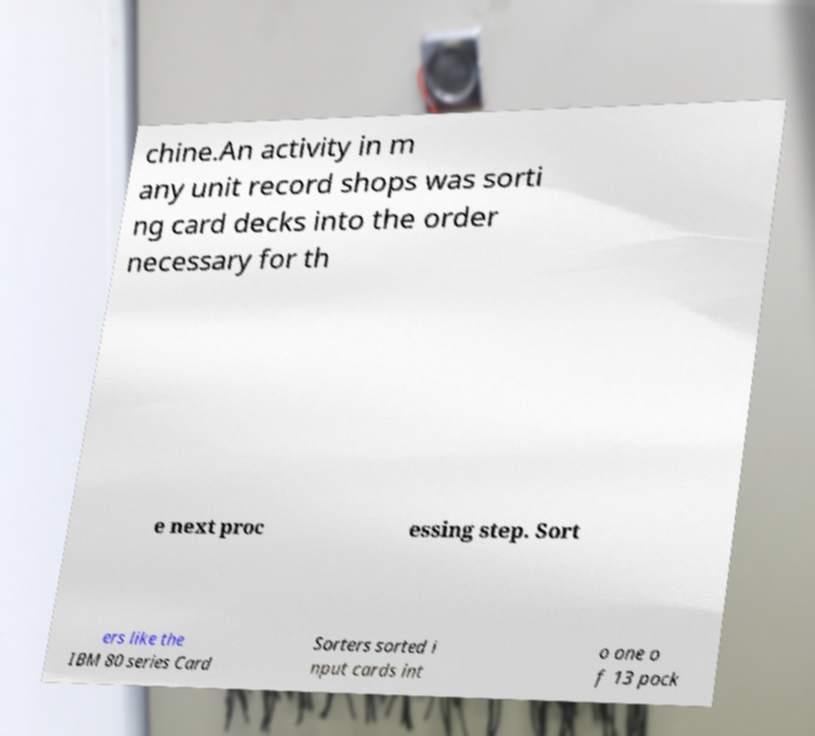There's text embedded in this image that I need extracted. Can you transcribe it verbatim? chine.An activity in m any unit record shops was sorti ng card decks into the order necessary for th e next proc essing step. Sort ers like the IBM 80 series Card Sorters sorted i nput cards int o one o f 13 pock 